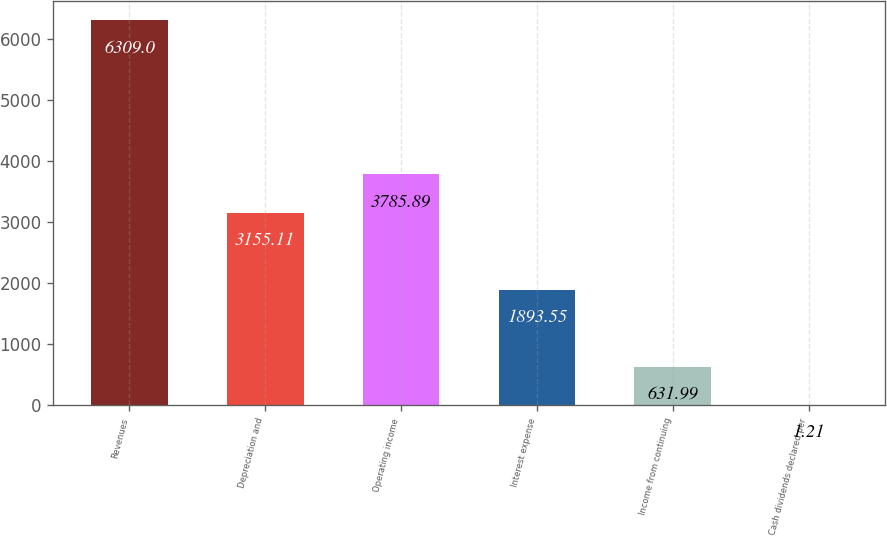Convert chart. <chart><loc_0><loc_0><loc_500><loc_500><bar_chart><fcel>Revenues<fcel>Depreciation and<fcel>Operating income<fcel>Interest expense<fcel>Income from continuing<fcel>Cash dividends declared per<nl><fcel>6309<fcel>3155.11<fcel>3785.89<fcel>1893.55<fcel>631.99<fcel>1.21<nl></chart> 